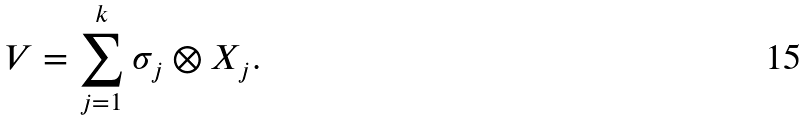<formula> <loc_0><loc_0><loc_500><loc_500>V = \sum _ { j = 1 } ^ { k } \sigma _ { j } \otimes X _ { j } .</formula> 